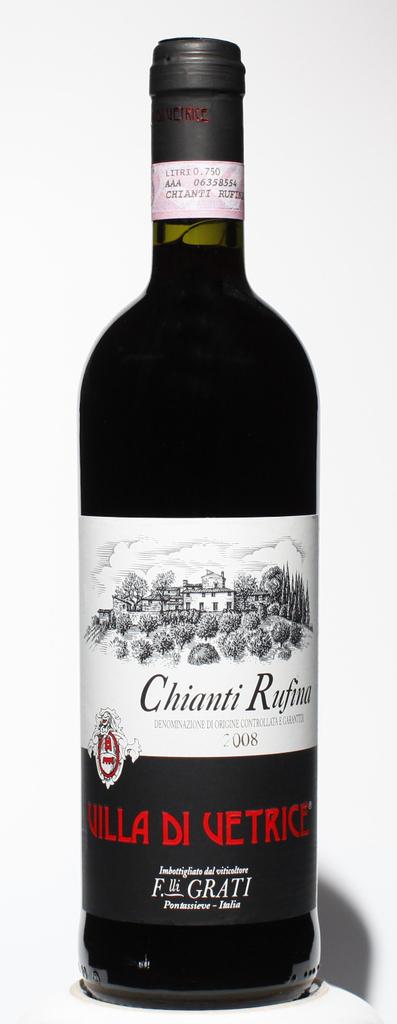What type of wine is pictured?
Make the answer very short. Chianti rufina. What year was the wine made?
Provide a short and direct response. 2008. 